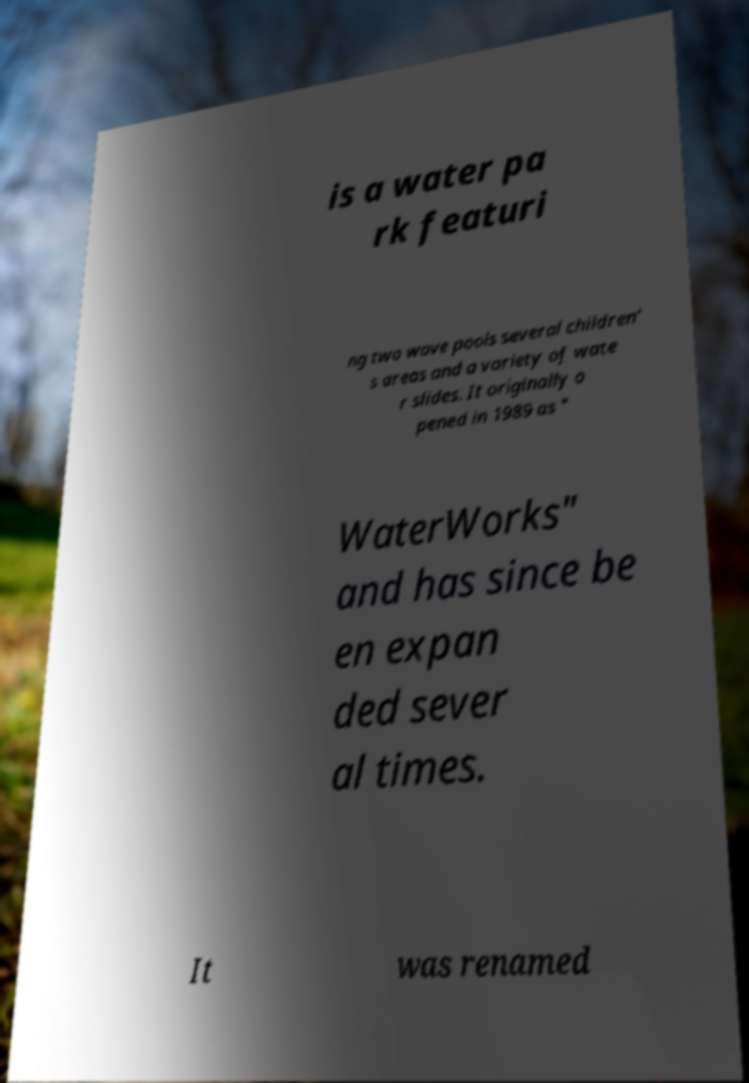There's text embedded in this image that I need extracted. Can you transcribe it verbatim? is a water pa rk featuri ng two wave pools several children' s areas and a variety of wate r slides. It originally o pened in 1989 as " WaterWorks" and has since be en expan ded sever al times. It was renamed 